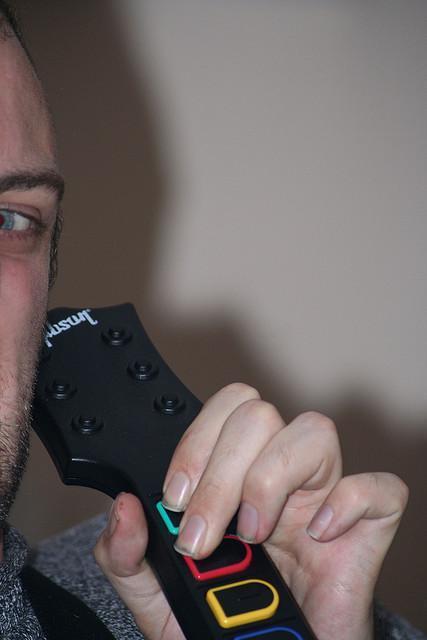How many fingers are touching the device?
Give a very brief answer. 4. How many remotes are in the picture?
Give a very brief answer. 1. How many white toy boats with blue rim floating in the pond ?
Give a very brief answer. 0. 